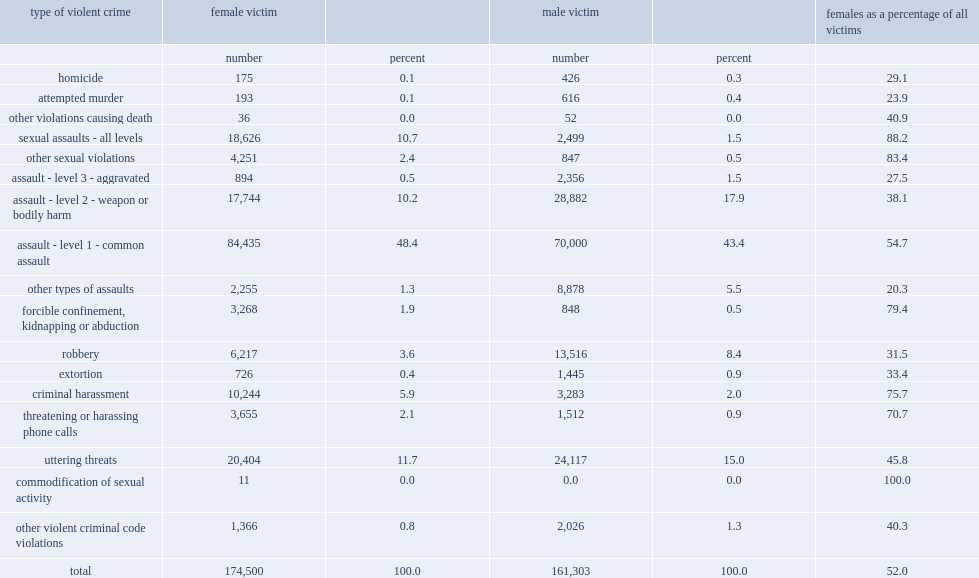List two types of crimes with the highest percentage of female victims except for "commodification of sexual activity". Sexual assaults - all levels other sexual violations. List three types of crimes with the highest percentage of female victims following other sexual violations. Forcible confinement, kidnapping or abduction criminal harassment threatening or harassing phone calls. Which sex comprises the whole victims of offences under the "commodification of sexual activity" category? Female victim. 